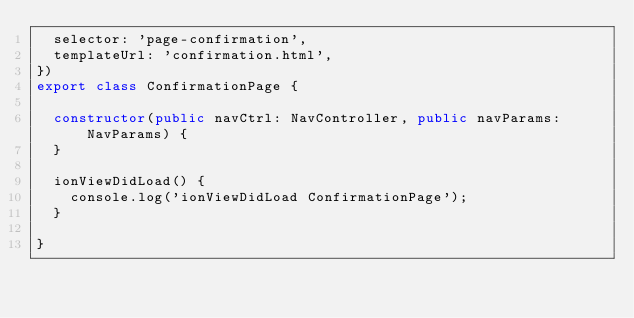<code> <loc_0><loc_0><loc_500><loc_500><_TypeScript_>  selector: 'page-confirmation',
  templateUrl: 'confirmation.html',
})
export class ConfirmationPage {

  constructor(public navCtrl: NavController, public navParams: NavParams) {
  }

  ionViewDidLoad() {
    console.log('ionViewDidLoad ConfirmationPage');
  }

}
</code> 